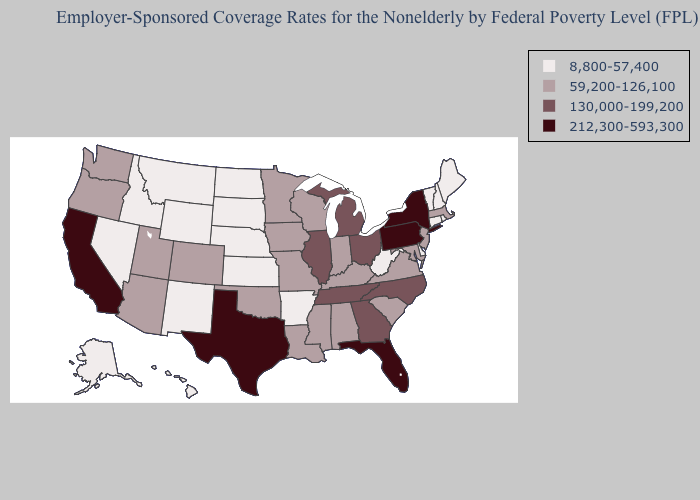Which states have the lowest value in the West?
Quick response, please. Alaska, Hawaii, Idaho, Montana, Nevada, New Mexico, Wyoming. Does Kansas have the lowest value in the USA?
Concise answer only. Yes. Does the first symbol in the legend represent the smallest category?
Write a very short answer. Yes. Among the states that border Oregon , which have the lowest value?
Concise answer only. Idaho, Nevada. Does Texas have the highest value in the South?
Write a very short answer. Yes. Name the states that have a value in the range 130,000-199,200?
Concise answer only. Georgia, Illinois, Michigan, North Carolina, Ohio, Tennessee. Name the states that have a value in the range 130,000-199,200?
Concise answer only. Georgia, Illinois, Michigan, North Carolina, Ohio, Tennessee. Does Texas have the highest value in the USA?
Give a very brief answer. Yes. Does Minnesota have a higher value than South Dakota?
Be succinct. Yes. Name the states that have a value in the range 130,000-199,200?
Write a very short answer. Georgia, Illinois, Michigan, North Carolina, Ohio, Tennessee. What is the lowest value in the MidWest?
Give a very brief answer. 8,800-57,400. Among the states that border Minnesota , which have the highest value?
Short answer required. Iowa, Wisconsin. Does Wyoming have the lowest value in the USA?
Be succinct. Yes. How many symbols are there in the legend?
Be succinct. 4. Name the states that have a value in the range 212,300-593,300?
Write a very short answer. California, Florida, New York, Pennsylvania, Texas. 